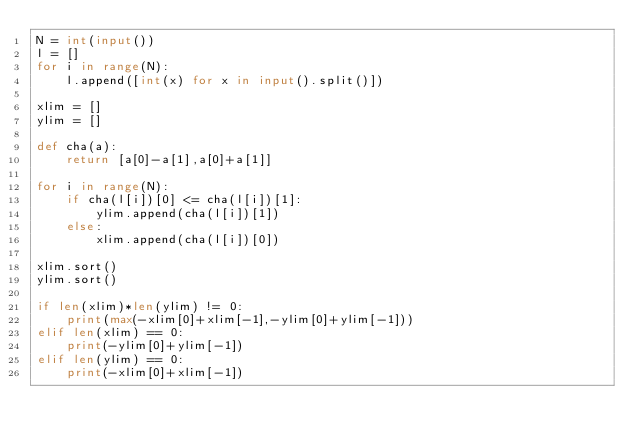Convert code to text. <code><loc_0><loc_0><loc_500><loc_500><_Python_>N = int(input())
l = []
for i in range(N):
    l.append([int(x) for x in input().split()])

xlim = []
ylim = []

def cha(a):
    return [a[0]-a[1],a[0]+a[1]]

for i in range(N):
    if cha(l[i])[0] <= cha(l[i])[1]:
        ylim.append(cha(l[i])[1])
    else:
        xlim.append(cha(l[i])[0])

xlim.sort()
ylim.sort()

if len(xlim)*len(ylim) != 0:
    print(max(-xlim[0]+xlim[-1],-ylim[0]+ylim[-1]))
elif len(xlim) == 0:
    print(-ylim[0]+ylim[-1])
elif len(ylim) == 0:
    print(-xlim[0]+xlim[-1])</code> 